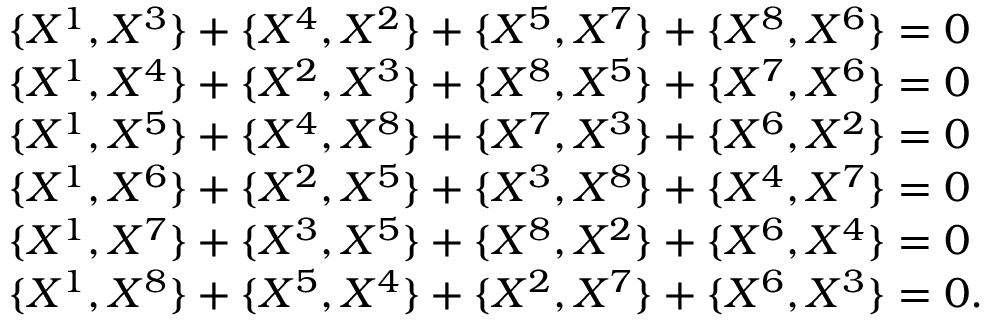Convert formula to latex. <formula><loc_0><loc_0><loc_500><loc_500>\begin{array} { l c r } { { \{ X ^ { 1 } , X ^ { 3 } \} + \{ X ^ { 4 } , X ^ { 2 } \} + \{ X ^ { 5 } , X ^ { 7 } \} + \{ X ^ { 8 } , X ^ { 6 } \} = 0 } } \\ { { \{ X ^ { 1 } , X ^ { 4 } \} + \{ X ^ { 2 } , X ^ { 3 } \} + \{ X ^ { 8 } , X ^ { 5 } \} + \{ X ^ { 7 } , X ^ { 6 } \} = 0 } } \\ { { \{ X ^ { 1 } , X ^ { 5 } \} + \{ X ^ { 4 } , X ^ { 8 } \} + \{ X ^ { 7 } , X ^ { 3 } \} + \{ X ^ { 6 } , X ^ { 2 } \} = 0 } } \\ { { \{ X ^ { 1 } , X ^ { 6 } \} + \{ X ^ { 2 } , X ^ { 5 } \} + \{ X ^ { 3 } , X ^ { 8 } \} + \{ X ^ { 4 } , X ^ { 7 } \} = 0 } } \\ { { \{ X ^ { 1 } , X ^ { 7 } \} + \{ X ^ { 3 } , X ^ { 5 } \} + \{ X ^ { 8 } , X ^ { 2 } \} + \{ X ^ { 6 } , X ^ { 4 } \} = 0 } } \\ { { \{ X ^ { 1 } , X ^ { 8 } \} + \{ X ^ { 5 } , X ^ { 4 } \} + \{ X ^ { 2 } , X ^ { 7 } \} + \{ X ^ { 6 } , X ^ { 3 } \} = 0 . } } \end{array}</formula> 